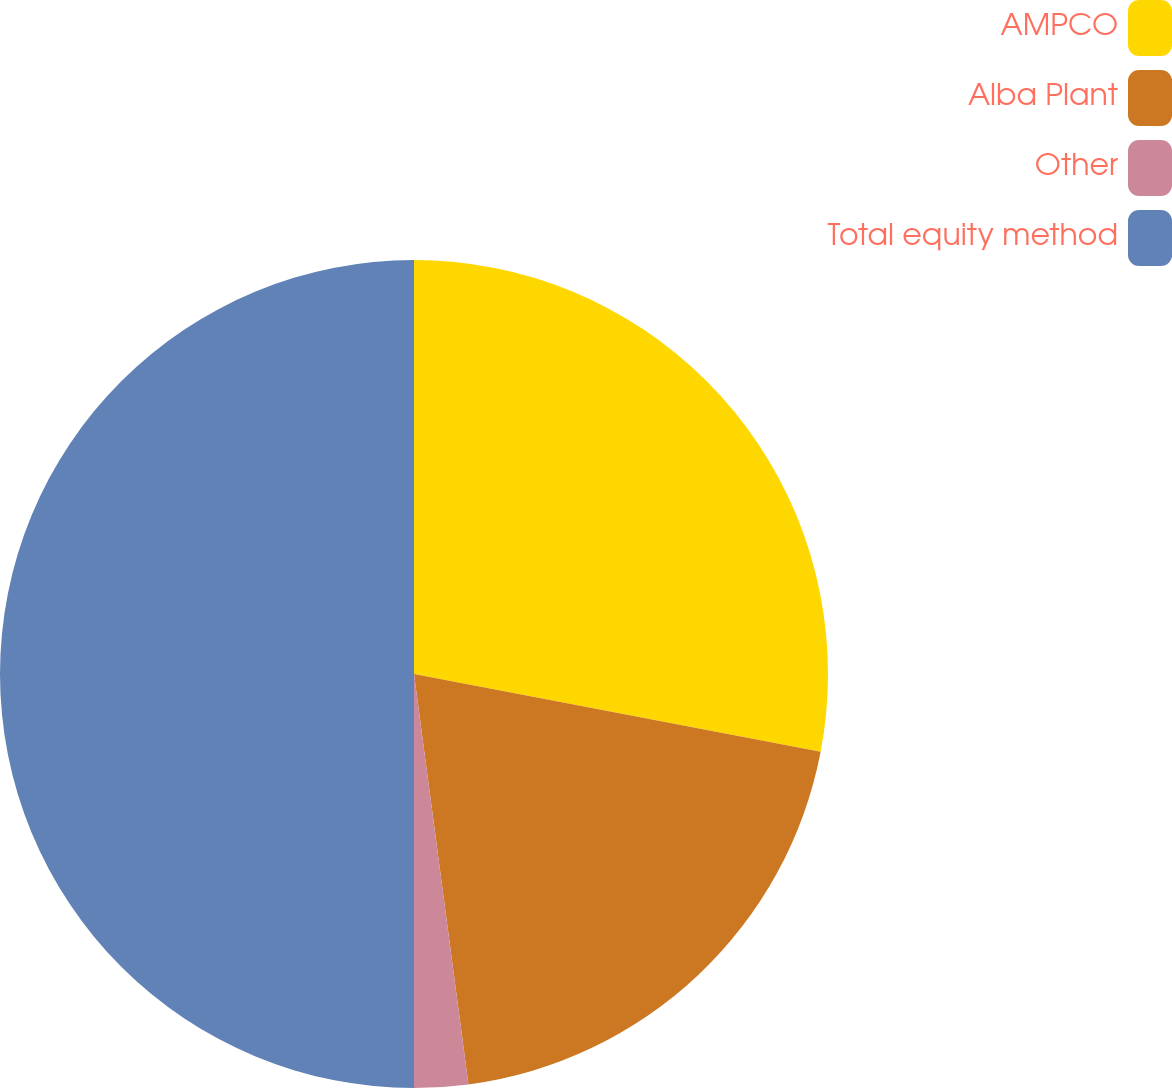Convert chart to OTSL. <chart><loc_0><loc_0><loc_500><loc_500><pie_chart><fcel>AMPCO<fcel>Alba Plant<fcel>Other<fcel>Total equity method<nl><fcel>28.01%<fcel>19.89%<fcel>2.1%<fcel>50.0%<nl></chart> 